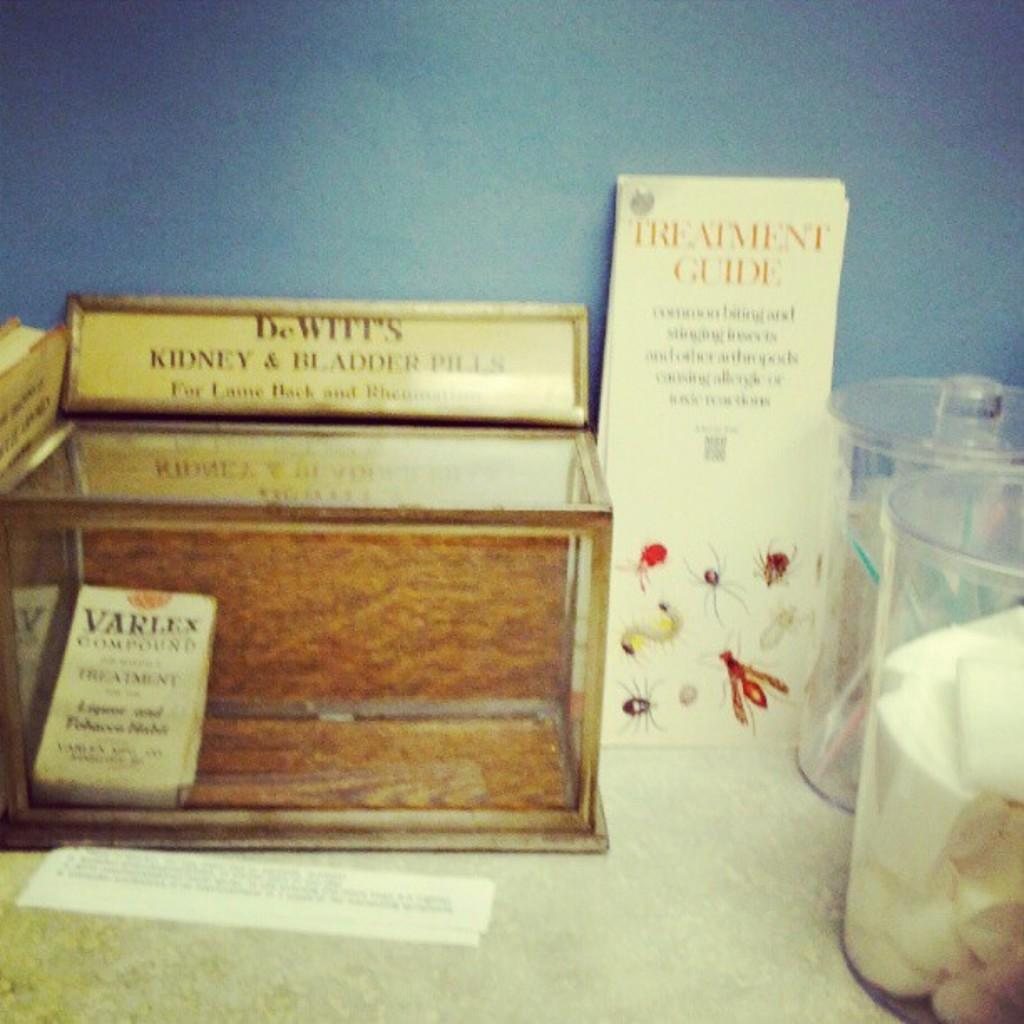<image>
Relay a brief, clear account of the picture shown. Dewitts Kidney and Gallbladder pills display cabinet sits on a table with other medical stuff. 